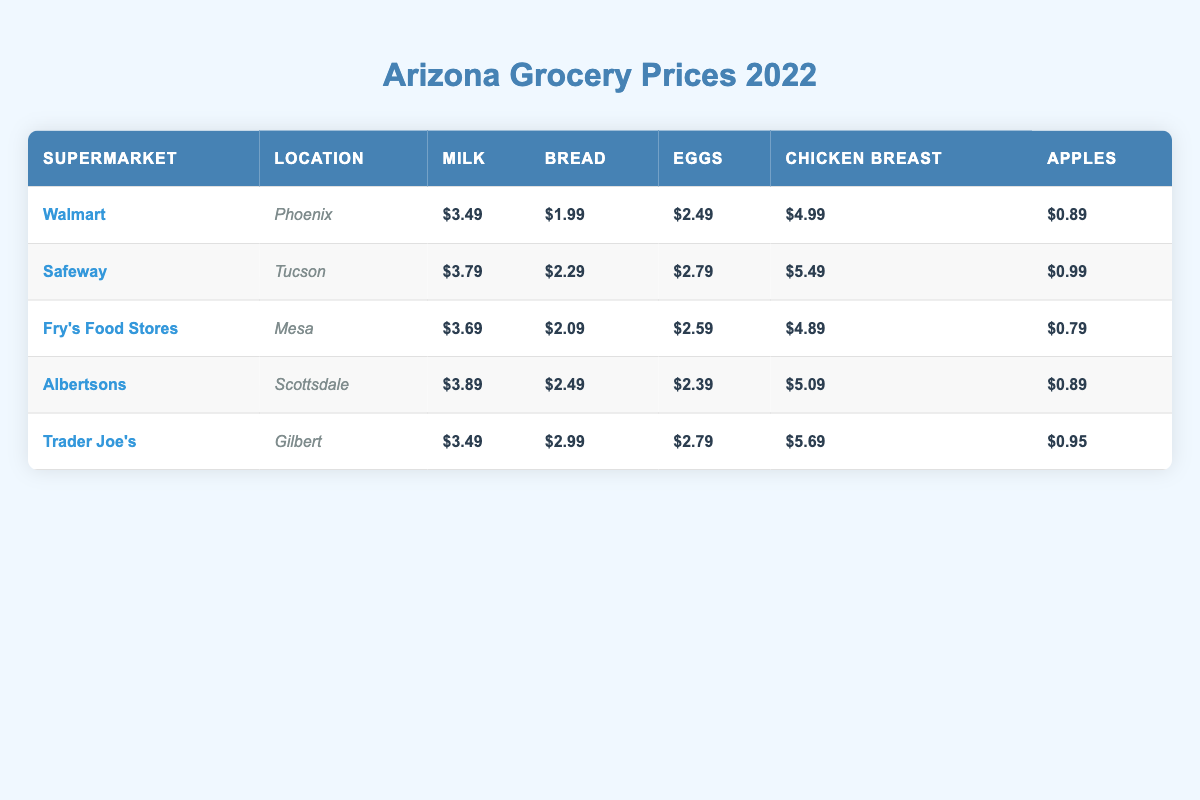What is the price of milk at Walmart in Phoenix? The table shows that Walmart, located in Phoenix, has a milk price of $3.49.
Answer: $3.49 Which supermarket offers the cheapest apples? By comparing the prices of apples from each supermarket: Walmart has $0.89, Safeway has $0.99, Fry's has $0.79, Albertsons has $0.89, and Trader Joe's has $0.95. The cheapest is Fry's Food Stores at $0.79.
Answer: $0.79 What is the average price of eggs across all supermarkets? To find the average price of eggs, first sum the prices: 2.49 + 2.79 + 2.59 + 2.39 + 2.79 = 13.05. Then, divide by the number of supermarkets, which is 5: 13.05/5 = 2.61.
Answer: $2.61 Is the price of chicken breast at Trader Joe's higher than at Safeway? Trader Joe's has a chicken breast price of $5.69 while Safeway's price is $5.49. Since $5.69 is greater than $5.49, it confirms that Trader Joe's is higher.
Answer: Yes What is the total cost of buying milk, bread, and eggs at Albertsons? To find the total cost, add the price of milk ($3.89), bread ($2.49), and eggs ($2.39) together: 3.89 + 2.49 + 2.39 = 8.77.
Answer: $8.77 What supermarket has the highest price for chicken breast? The chicken breast prices are: Walmart at $4.99, Safeway at $5.49, Fry's at $4.89, Albertsons at $5.09, and Trader Joe's at $5.69. Comparing these, Trader Joe’s has the highest price at $5.69.
Answer: Trader Joe's What is the difference in bread prices between Safeway and Fry's Food Stores? Safeway’s bread price is $2.29, and Fry's bread price is $2.09. To find the difference, subtract Fry's price from Safeway's: 2.29 - 2.09 = 0.20.
Answer: $0.20 How many supermarkets have milk prices below $4? The following supermarkets have milk prices below $4: Walmart ($3.49), Fry's ($3.69), and Trader Joe's ($3.49). This totals to 3 supermarkets.
Answer: 3 Which location has the second lowest price for bread? Bread prices are as follows: Walmart at $1.99, Fry’s at $2.09, Safeway at $2.29, Albertsons at $2.49, and Trader Joe's at $2.99. The second lowest price is Fry's at $2.09.
Answer: Fry's Food Stores 